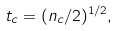Convert formula to latex. <formula><loc_0><loc_0><loc_500><loc_500>t _ { c } = ( n _ { c } / 2 ) ^ { 1 / 2 } ,</formula> 